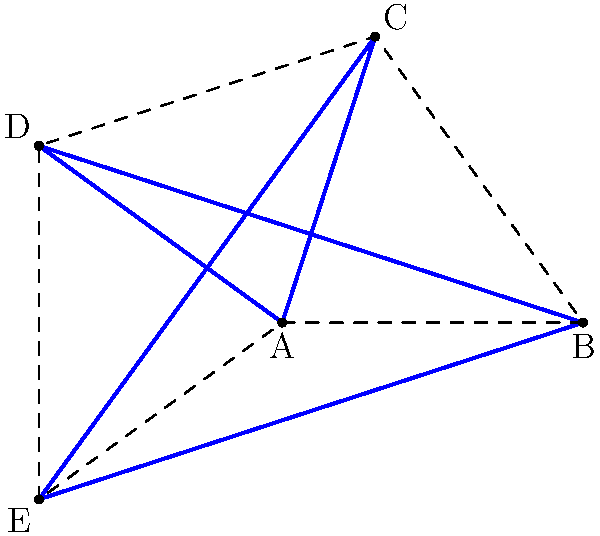In your latest street art-inspired painting, you've incorporated a perfect five-pointed star. If the internal angle at each point of the star is 36°, what is the measure of the central angle subtended by each arm of the star at the center? Let's approach this step-by-step:

1) First, recall that a regular pentagon forms the outer shape of a perfect five-pointed star.

2) The internal angle of a regular pentagon is calculated as:
   $$(n-2) \times 180° \div n = (5-2) \times 180° \div 5 = 108°$$

3) In a perfect five-pointed star, each point divides this 108° angle into three parts:
   - The internal angle of the star point (given as 36°)
   - Two equal angles formed by the star's arms

4) Let's call the angle formed by each arm $x$. Then:
   $$36° + x + x = 108°$$
   $$36° + 2x = 108°$$
   $$2x = 72°$$
   $$x = 36°$$

5) This $x$ is the angle at the center between the arm of the star and the line to the adjacent vertex of the pentagon.

6) The central angle subtended by each arm is twice this angle:
   $$2 \times 36° = 72°$$

Therefore, the central angle subtended by each arm of the star at the center is 72°.
Answer: 72° 